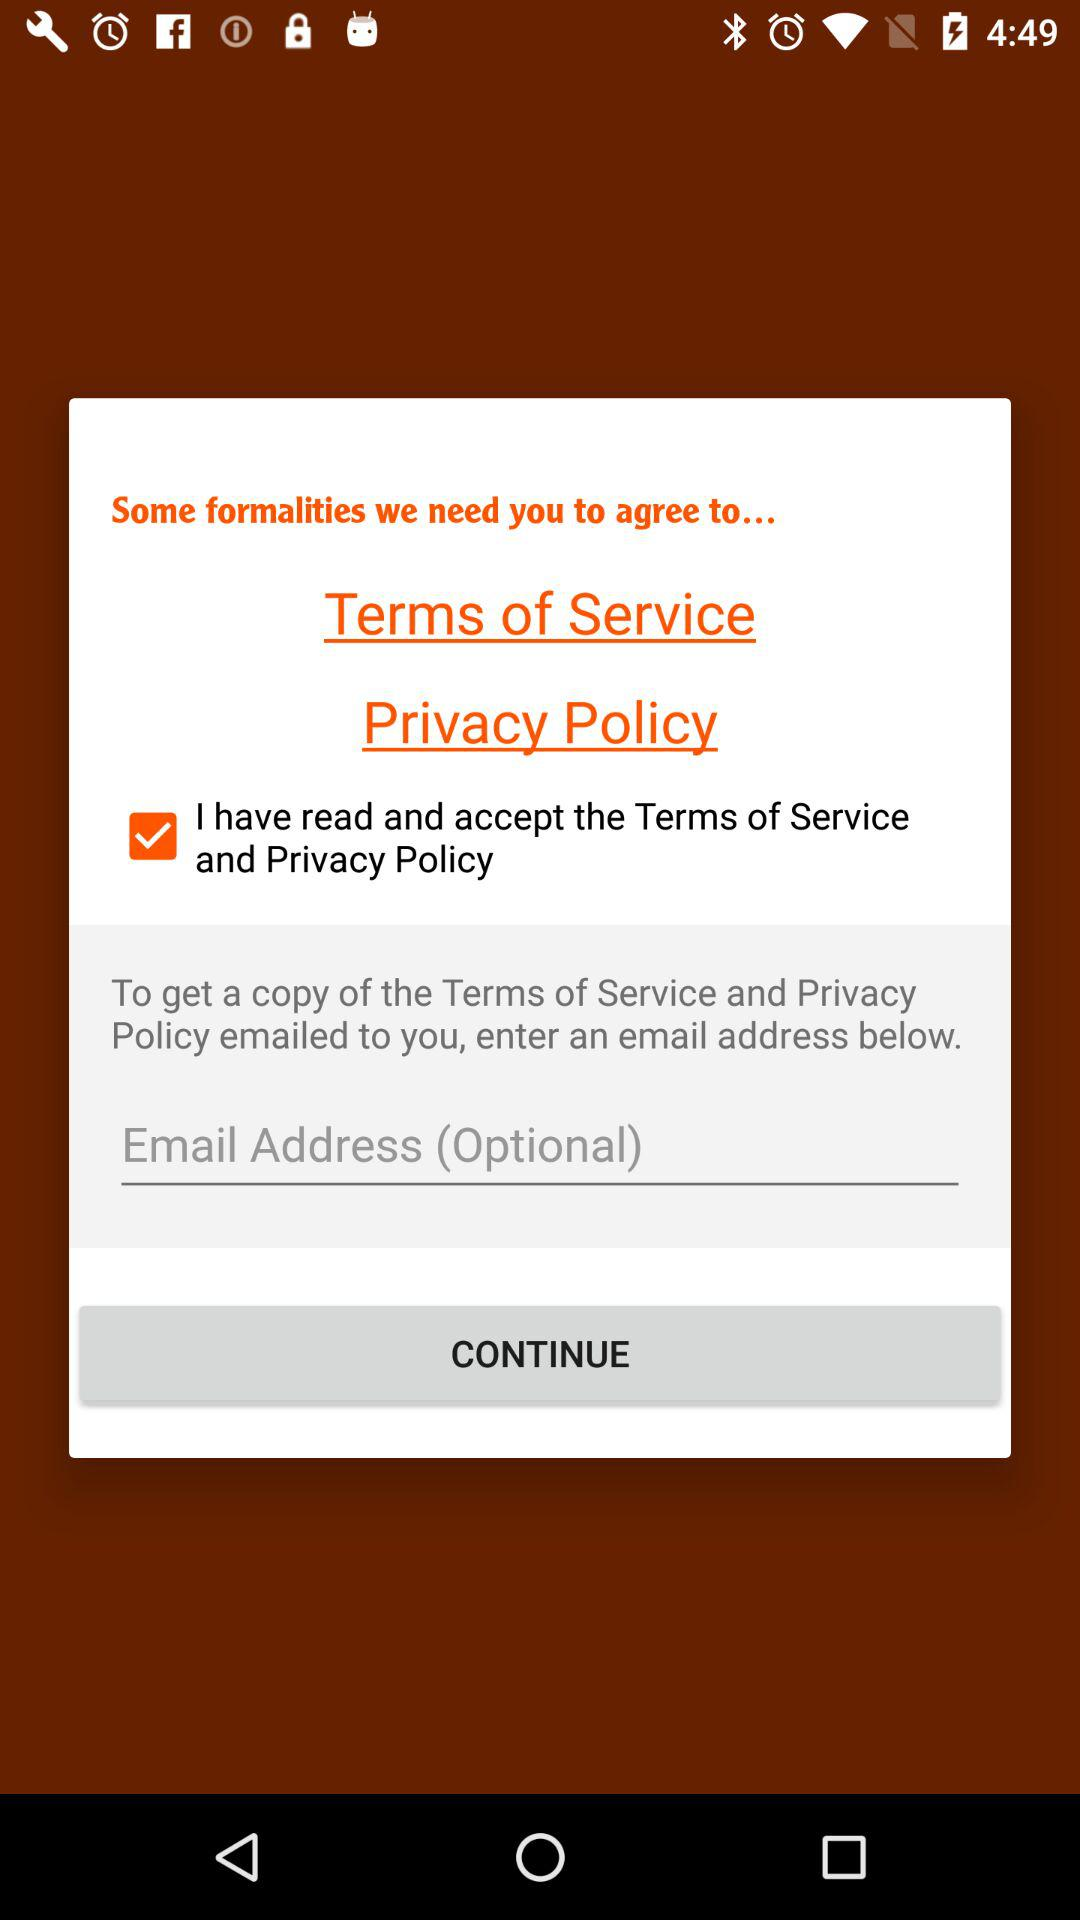What is the status of the "Terms of Service and Privacy Policy"? The status is "on". 